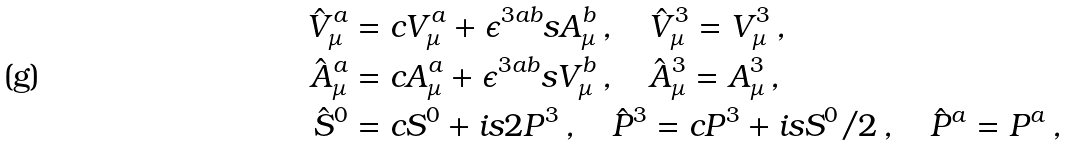Convert formula to latex. <formula><loc_0><loc_0><loc_500><loc_500>\hat { V } _ { \mu } ^ { a } & = c V _ { \mu } ^ { a } + \epsilon ^ { 3 a b } s A _ { \mu } ^ { b } \, , \quad \hat { V } _ { \mu } ^ { 3 } = V _ { \mu } ^ { 3 } \, , \\ \hat { A } _ { \mu } ^ { a } & = c A _ { \mu } ^ { a } + \epsilon ^ { 3 a b } s V _ { \mu } ^ { b } \, , \quad \hat { A } _ { \mu } ^ { 3 } = A _ { \mu } ^ { 3 } \, , \\ \hat { S } ^ { 0 } & = c S ^ { 0 } + i s 2 P ^ { 3 } \, , \quad \hat { P } ^ { 3 } = c P ^ { 3 } + i s S ^ { 0 } / 2 \, , \quad \hat { P } ^ { a } = P ^ { a } \, ,</formula> 